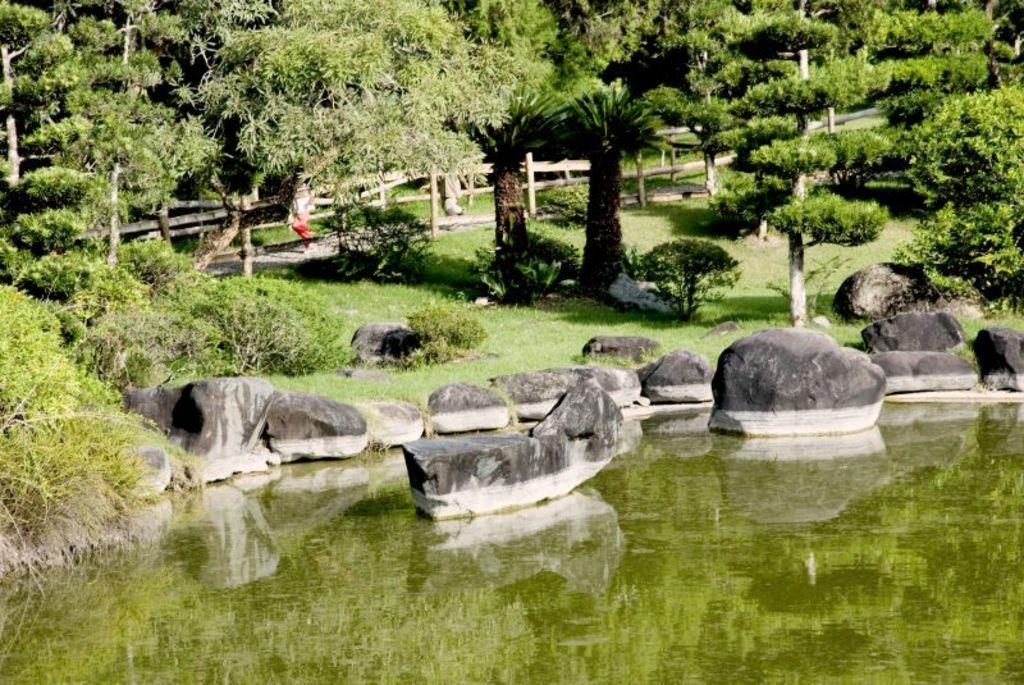What type of vegetation can be seen in the image? There are trees, plants, and grass visible in the image. What type of ground cover is present in the image? There are stones in the image. What is the water feature in the image? Water is visible in the image. What type of barrier is present in the image? There is a fence in the image. What are the two persons in the image doing? Two persons are walking on the pavement in the image. What type of pain is the person in the image experiencing? There is no indication of pain or discomfort in the image; the two persons are walking on the pavement. What type of birthday celebration is taking place in the image? There is no birthday celebration or any reference to a birthday in the image. 